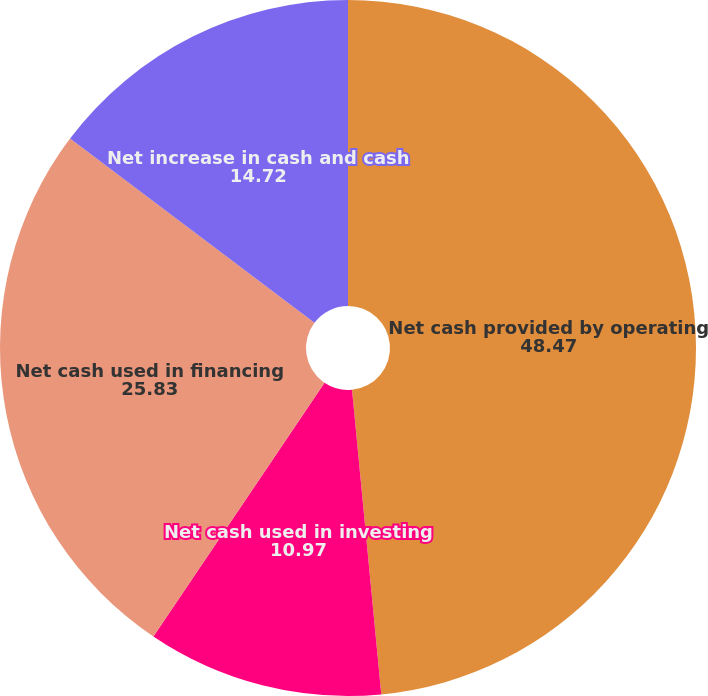Convert chart. <chart><loc_0><loc_0><loc_500><loc_500><pie_chart><fcel>Net cash provided by operating<fcel>Net cash used in investing<fcel>Net cash used in financing<fcel>Net increase in cash and cash<nl><fcel>48.47%<fcel>10.97%<fcel>25.83%<fcel>14.72%<nl></chart> 